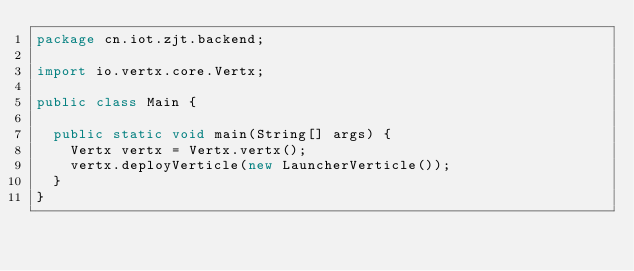Convert code to text. <code><loc_0><loc_0><loc_500><loc_500><_Java_>package cn.iot.zjt.backend;

import io.vertx.core.Vertx;

public class Main {

  public static void main(String[] args) {
    Vertx vertx = Vertx.vertx();
    vertx.deployVerticle(new LauncherVerticle());
  }
}
</code> 